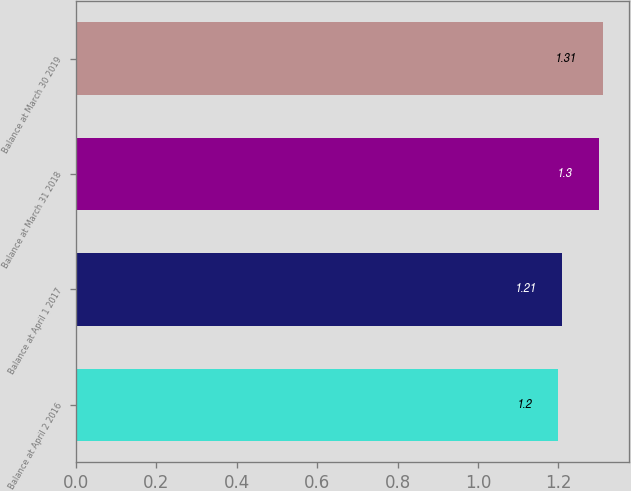Convert chart. <chart><loc_0><loc_0><loc_500><loc_500><bar_chart><fcel>Balance at April 2 2016<fcel>Balance at April 1 2017<fcel>Balance at March 31 2018<fcel>Balance at March 30 2019<nl><fcel>1.2<fcel>1.21<fcel>1.3<fcel>1.31<nl></chart> 